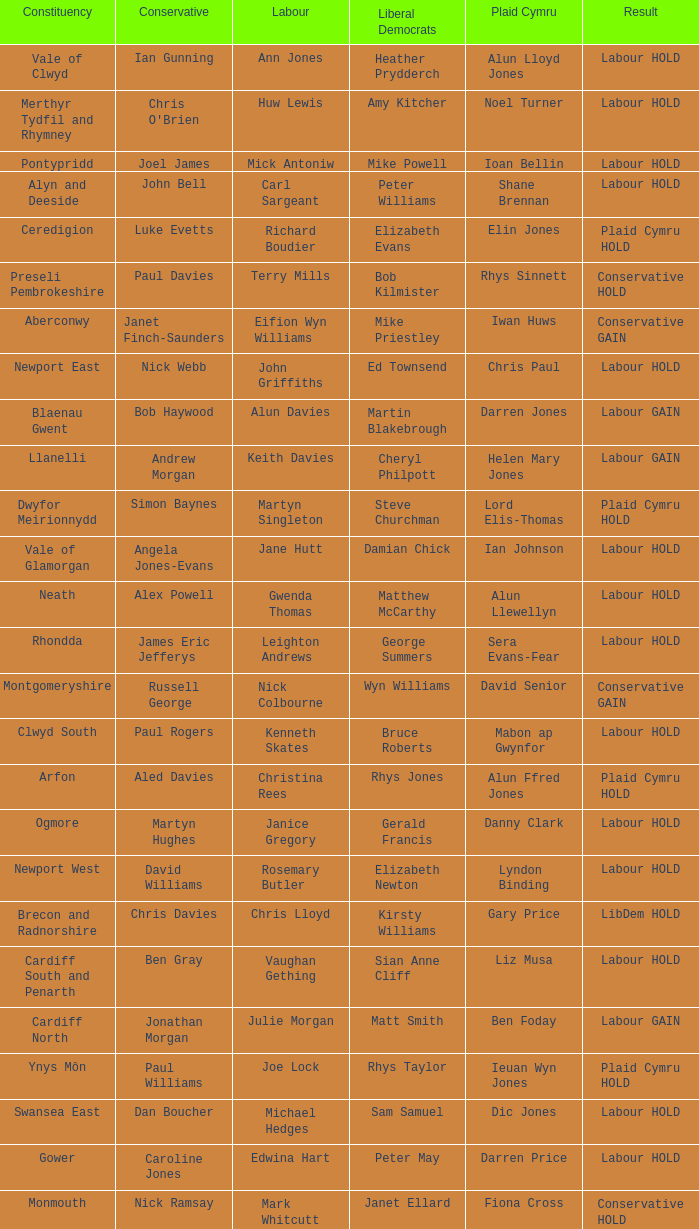In what constituency was the result labour hold and Liberal democrat Elizabeth Newton won? Newport West. 